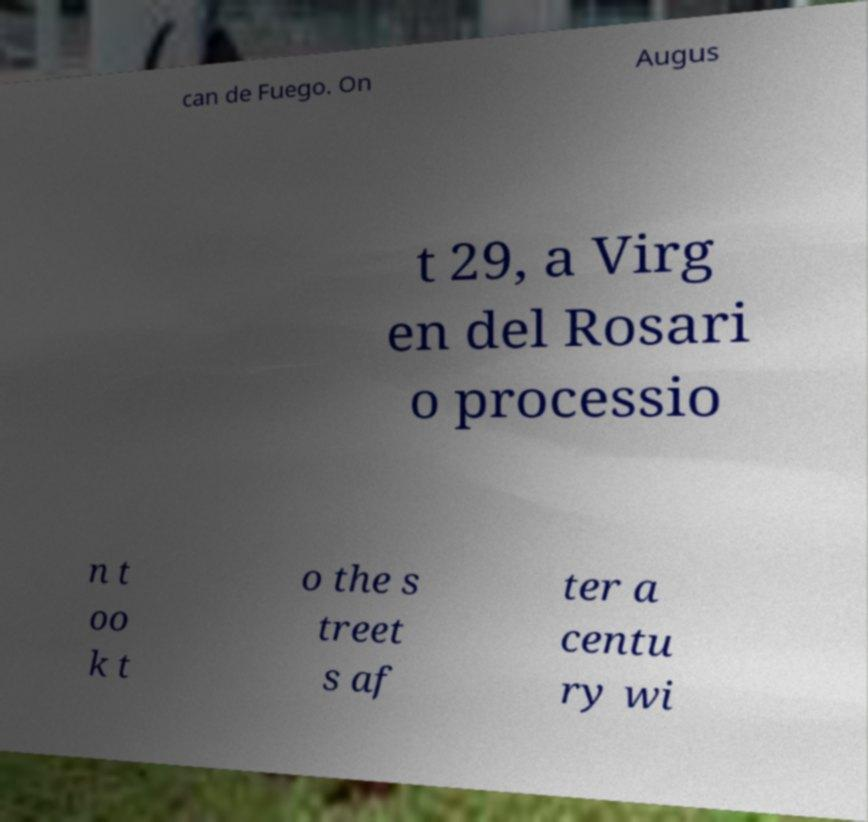Could you extract and type out the text from this image? can de Fuego. On Augus t 29, a Virg en del Rosari o processio n t oo k t o the s treet s af ter a centu ry wi 